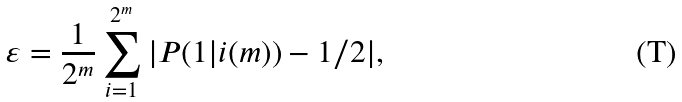Convert formula to latex. <formula><loc_0><loc_0><loc_500><loc_500>\varepsilon = \frac { 1 } { 2 ^ { m } } \sum _ { i = 1 } ^ { 2 ^ { m } } | P ( 1 | i ( m ) ) - 1 / 2 | ,</formula> 